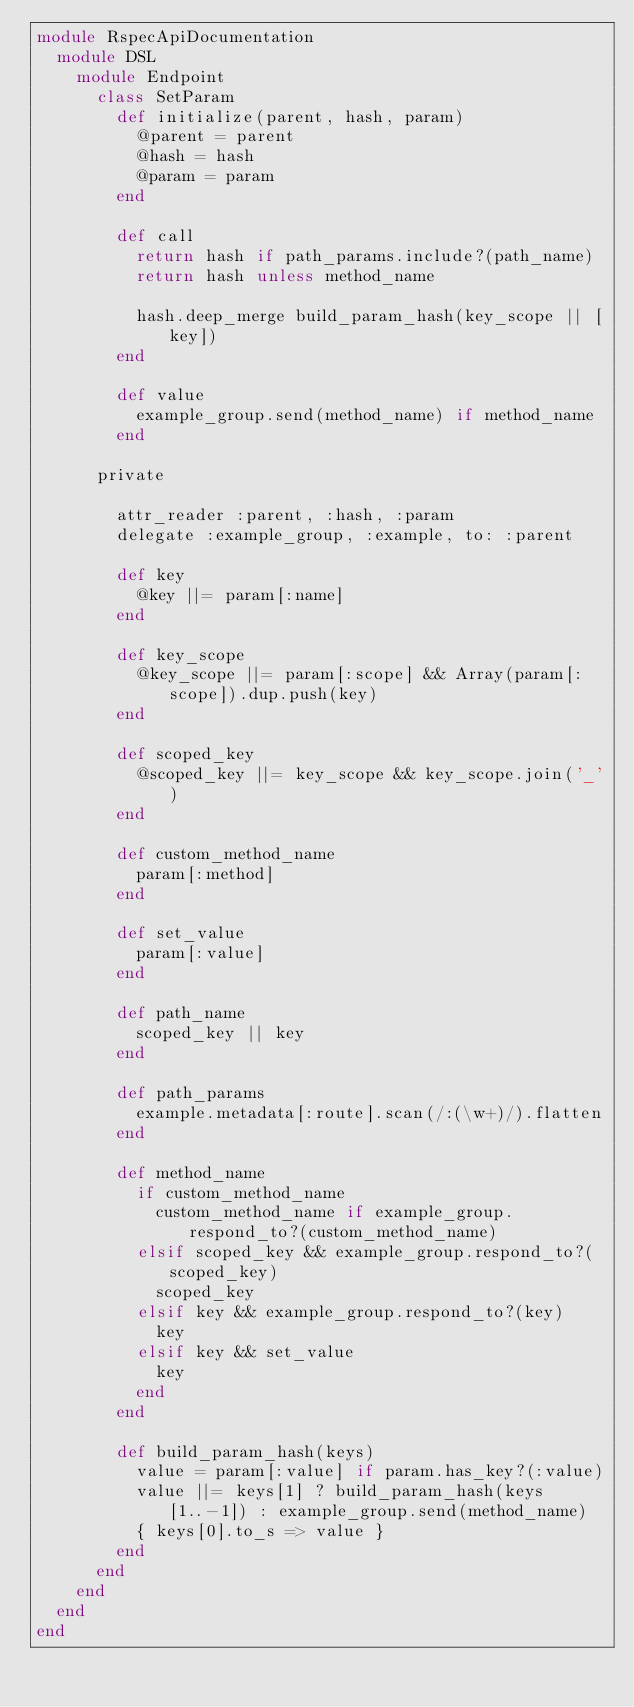<code> <loc_0><loc_0><loc_500><loc_500><_Ruby_>module RspecApiDocumentation
  module DSL
    module Endpoint
      class SetParam
        def initialize(parent, hash, param)
          @parent = parent
          @hash = hash
          @param = param
        end

        def call
          return hash if path_params.include?(path_name)
          return hash unless method_name

          hash.deep_merge build_param_hash(key_scope || [key])
        end

        def value
          example_group.send(method_name) if method_name
        end

      private

        attr_reader :parent, :hash, :param
        delegate :example_group, :example, to: :parent

        def key
          @key ||= param[:name]
        end

        def key_scope
          @key_scope ||= param[:scope] && Array(param[:scope]).dup.push(key)
        end

        def scoped_key
          @scoped_key ||= key_scope && key_scope.join('_')
        end

        def custom_method_name
          param[:method]
        end

        def set_value
          param[:value]
        end

        def path_name
          scoped_key || key
        end

        def path_params
          example.metadata[:route].scan(/:(\w+)/).flatten
        end

        def method_name
          if custom_method_name
            custom_method_name if example_group.respond_to?(custom_method_name)
          elsif scoped_key && example_group.respond_to?(scoped_key)
            scoped_key
          elsif key && example_group.respond_to?(key)
            key
          elsif key && set_value
            key
          end
        end

        def build_param_hash(keys)
          value = param[:value] if param.has_key?(:value)
          value ||= keys[1] ? build_param_hash(keys[1..-1]) : example_group.send(method_name)
          { keys[0].to_s => value }
        end
      end
    end
  end
end
</code> 